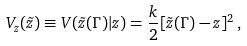Convert formula to latex. <formula><loc_0><loc_0><loc_500><loc_500>V _ { z } ( \tilde { z } ) \equiv V ( \tilde { z } ( \Gamma ) | z ) = \frac { k } { 2 } [ \tilde { z } ( \Gamma ) - z ] ^ { 2 } \, ,</formula> 